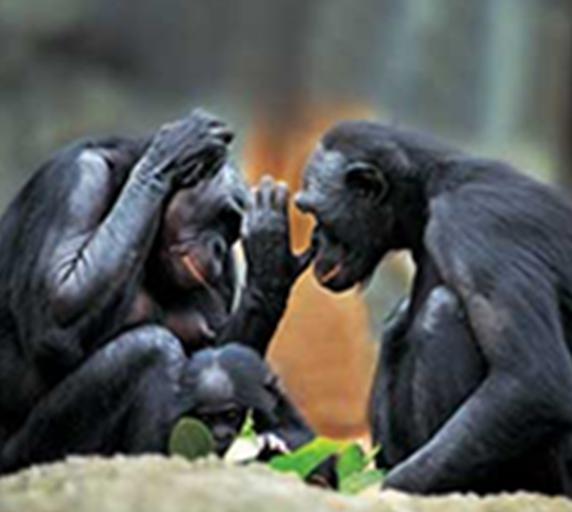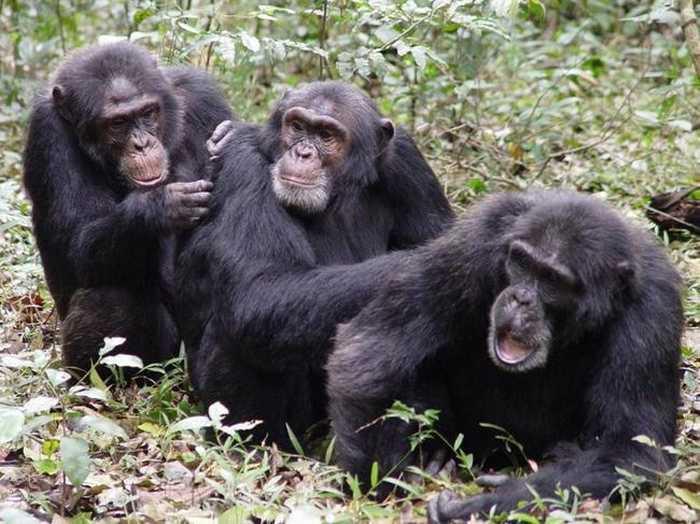The first image is the image on the left, the second image is the image on the right. Given the left and right images, does the statement "One image includes two apes sitting directly face to face, while the other image features chimps sitting one behind the other." hold true? Answer yes or no. Yes. The first image is the image on the left, the second image is the image on the right. Analyze the images presented: Is the assertion "There is exactly three chimpanzees in the right image." valid? Answer yes or no. Yes. 